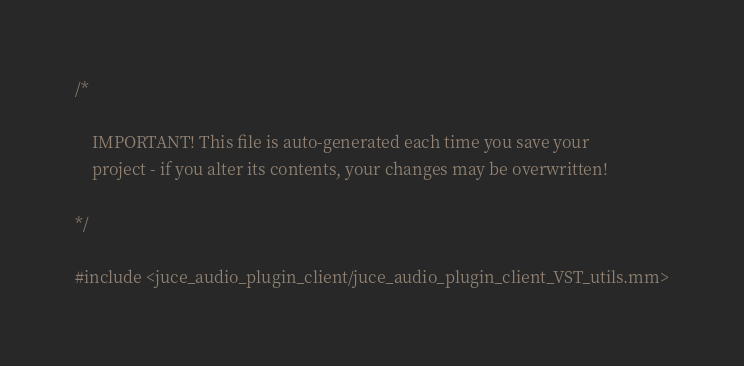<code> <loc_0><loc_0><loc_500><loc_500><_ObjectiveC_>/*

    IMPORTANT! This file is auto-generated each time you save your
    project - if you alter its contents, your changes may be overwritten!

*/

#include <juce_audio_plugin_client/juce_audio_plugin_client_VST_utils.mm>
</code> 